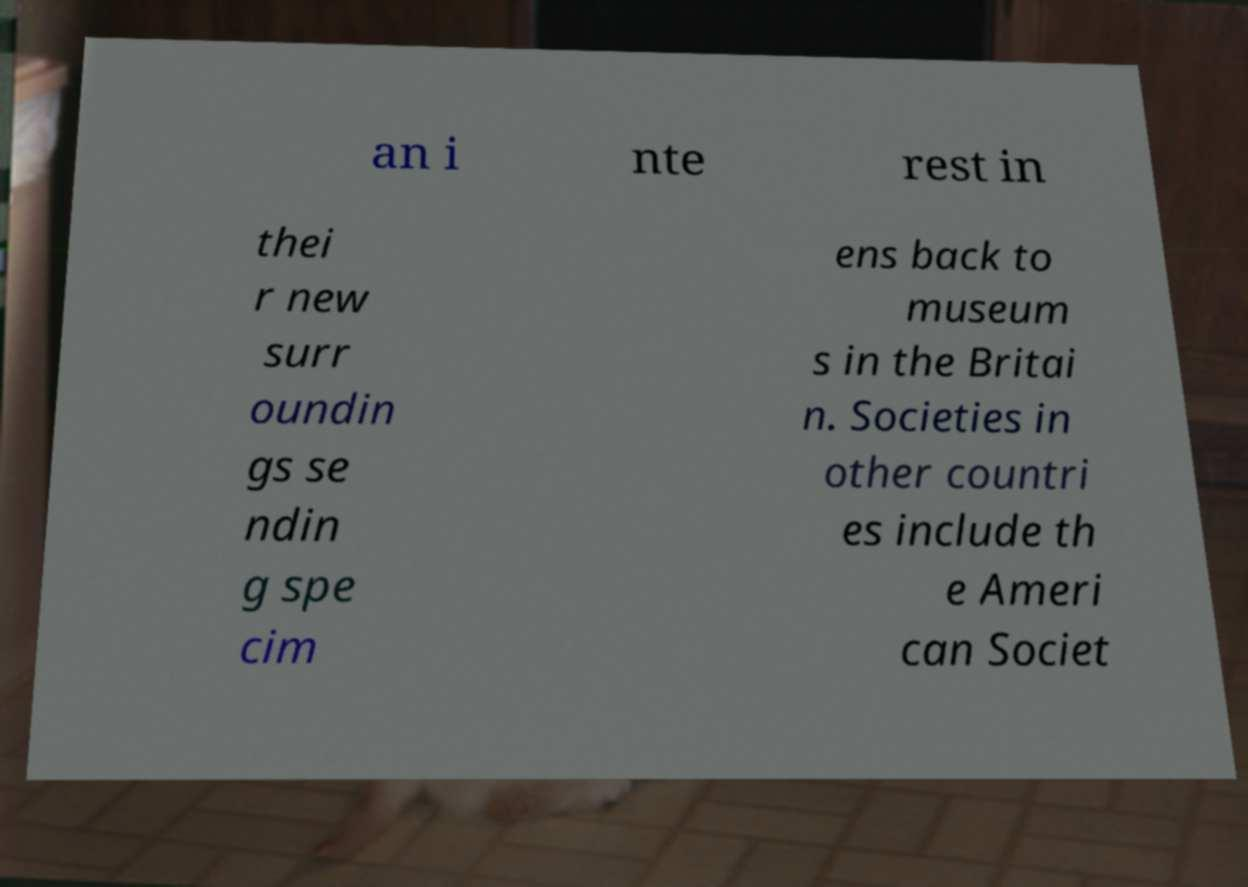Can you read and provide the text displayed in the image?This photo seems to have some interesting text. Can you extract and type it out for me? an i nte rest in thei r new surr oundin gs se ndin g spe cim ens back to museum s in the Britai n. Societies in other countri es include th e Ameri can Societ 